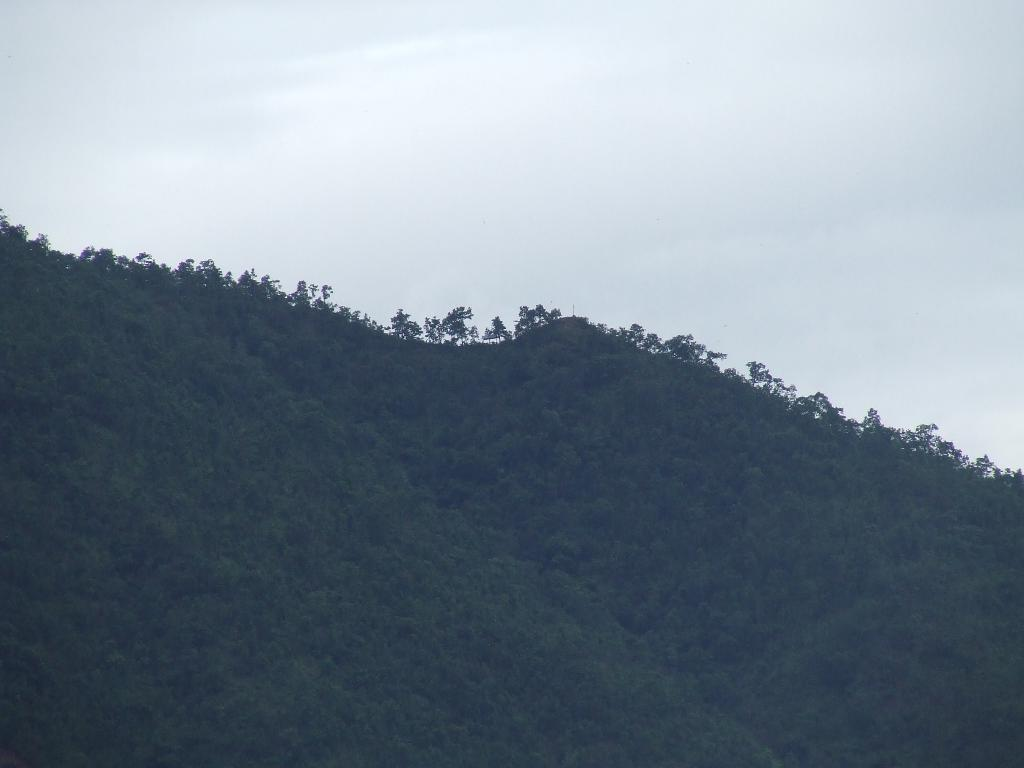What is the main subject of the image? The main subject of the image is a mountain. What can be observed on the mountain's surface? The mountain is covered with plants. What is present at the top of the mountain? There are clouds at the top of the mountain, and the sky is also visible. How many docks can be seen near the mountain in the image? There are no docks present in the image; it features a mountain with plants and clouds. What type of wilderness is visible in the image? The image does not specifically depict a wilderness area, but it does show a mountain covered with plants and surrounded by clouds. 